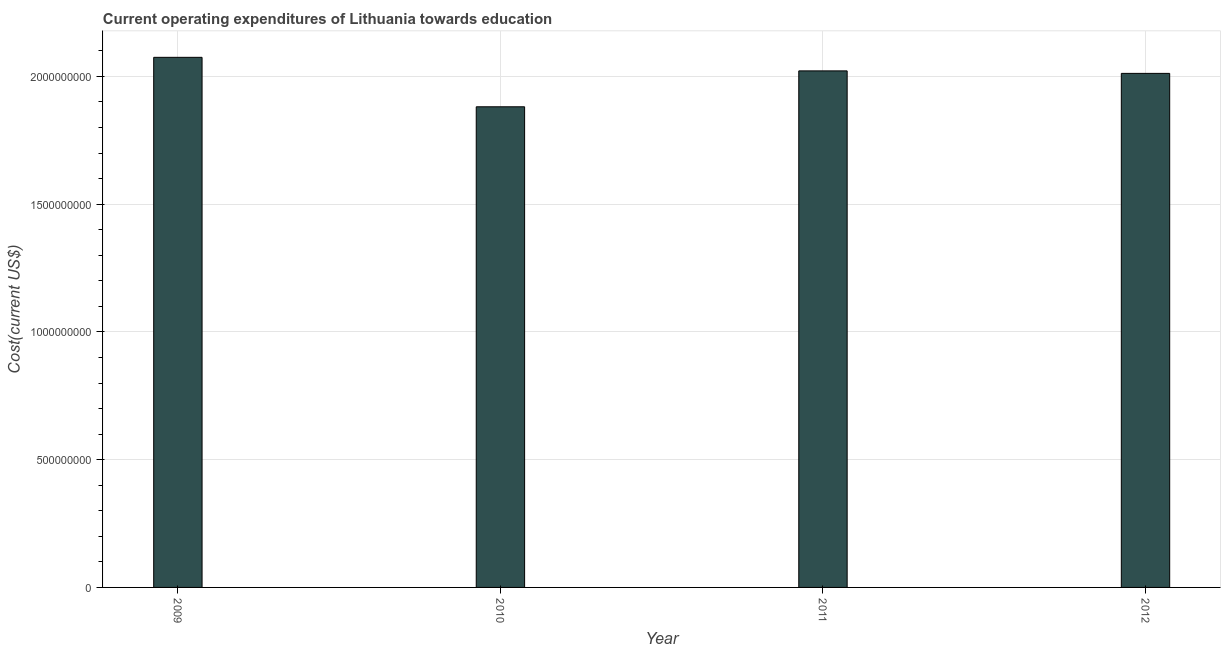Does the graph contain any zero values?
Your answer should be compact. No. Does the graph contain grids?
Provide a short and direct response. Yes. What is the title of the graph?
Provide a short and direct response. Current operating expenditures of Lithuania towards education. What is the label or title of the Y-axis?
Your answer should be very brief. Cost(current US$). What is the education expenditure in 2011?
Your answer should be compact. 2.02e+09. Across all years, what is the maximum education expenditure?
Offer a terse response. 2.07e+09. Across all years, what is the minimum education expenditure?
Ensure brevity in your answer.  1.88e+09. In which year was the education expenditure maximum?
Ensure brevity in your answer.  2009. In which year was the education expenditure minimum?
Provide a succinct answer. 2010. What is the sum of the education expenditure?
Your answer should be compact. 7.99e+09. What is the difference between the education expenditure in 2009 and 2010?
Provide a short and direct response. 1.94e+08. What is the average education expenditure per year?
Provide a short and direct response. 2.00e+09. What is the median education expenditure?
Make the answer very short. 2.02e+09. Do a majority of the years between 2011 and 2012 (inclusive) have education expenditure greater than 1900000000 US$?
Your answer should be very brief. Yes. What is the ratio of the education expenditure in 2009 to that in 2010?
Give a very brief answer. 1.1. Is the education expenditure in 2009 less than that in 2011?
Provide a succinct answer. No. Is the difference between the education expenditure in 2010 and 2012 greater than the difference between any two years?
Offer a terse response. No. What is the difference between the highest and the second highest education expenditure?
Offer a very short reply. 5.31e+07. Is the sum of the education expenditure in 2010 and 2012 greater than the maximum education expenditure across all years?
Your response must be concise. Yes. What is the difference between the highest and the lowest education expenditure?
Make the answer very short. 1.94e+08. In how many years, is the education expenditure greater than the average education expenditure taken over all years?
Your answer should be compact. 3. How many bars are there?
Offer a very short reply. 4. Are all the bars in the graph horizontal?
Provide a short and direct response. No. What is the difference between two consecutive major ticks on the Y-axis?
Provide a succinct answer. 5.00e+08. What is the Cost(current US$) in 2009?
Give a very brief answer. 2.07e+09. What is the Cost(current US$) of 2010?
Your answer should be compact. 1.88e+09. What is the Cost(current US$) in 2011?
Your answer should be very brief. 2.02e+09. What is the Cost(current US$) of 2012?
Your answer should be compact. 2.01e+09. What is the difference between the Cost(current US$) in 2009 and 2010?
Provide a short and direct response. 1.94e+08. What is the difference between the Cost(current US$) in 2009 and 2011?
Provide a short and direct response. 5.31e+07. What is the difference between the Cost(current US$) in 2009 and 2012?
Offer a very short reply. 6.28e+07. What is the difference between the Cost(current US$) in 2010 and 2011?
Your response must be concise. -1.40e+08. What is the difference between the Cost(current US$) in 2010 and 2012?
Keep it short and to the point. -1.31e+08. What is the difference between the Cost(current US$) in 2011 and 2012?
Your answer should be very brief. 9.74e+06. What is the ratio of the Cost(current US$) in 2009 to that in 2010?
Ensure brevity in your answer.  1.1. What is the ratio of the Cost(current US$) in 2009 to that in 2011?
Offer a very short reply. 1.03. What is the ratio of the Cost(current US$) in 2009 to that in 2012?
Your response must be concise. 1.03. What is the ratio of the Cost(current US$) in 2010 to that in 2011?
Give a very brief answer. 0.93. What is the ratio of the Cost(current US$) in 2010 to that in 2012?
Provide a short and direct response. 0.94. 